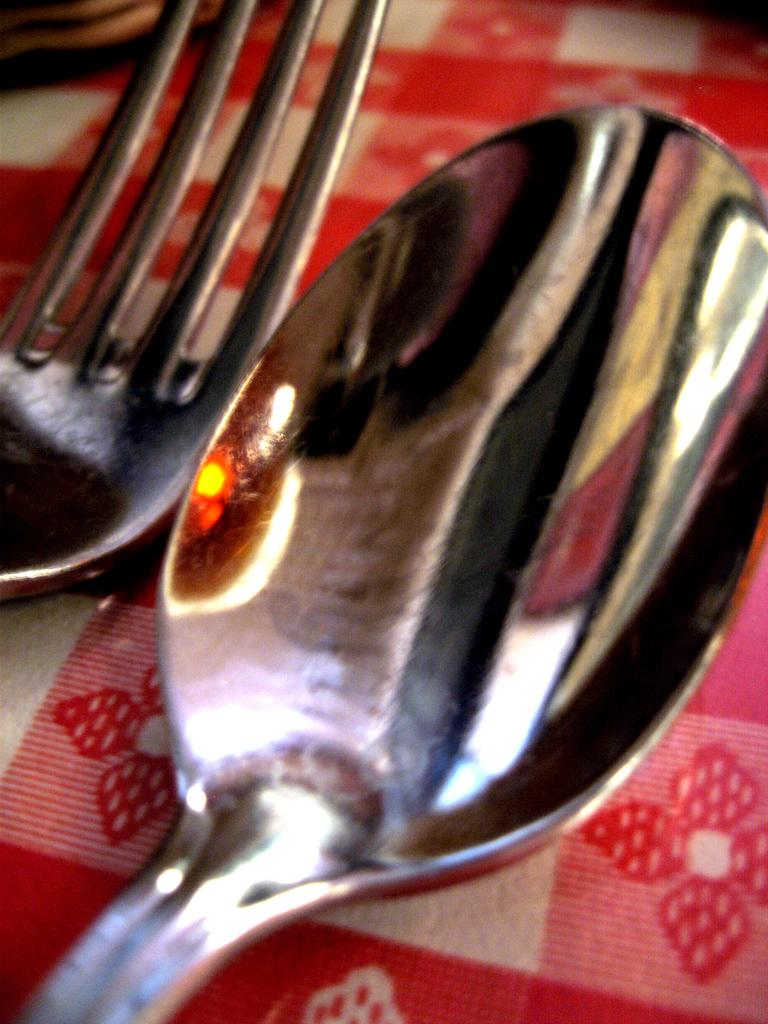What color is the cloth that is visible in the image? There is a red cloth in the image. What objects are on the red cloth? There is a spoon and a fork on the red cloth. Can you see a tiger hiding behind the red cloth in the image? There is no tiger present in the image. What type of sack is placed on the red cloth in the image? There is no sack present on the red cloth in the image. 